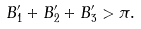Convert formula to latex. <formula><loc_0><loc_0><loc_500><loc_500>B ^ { \prime } _ { 1 } + B ^ { \prime } _ { 2 } + B ^ { \prime } _ { 3 } > \pi .</formula> 